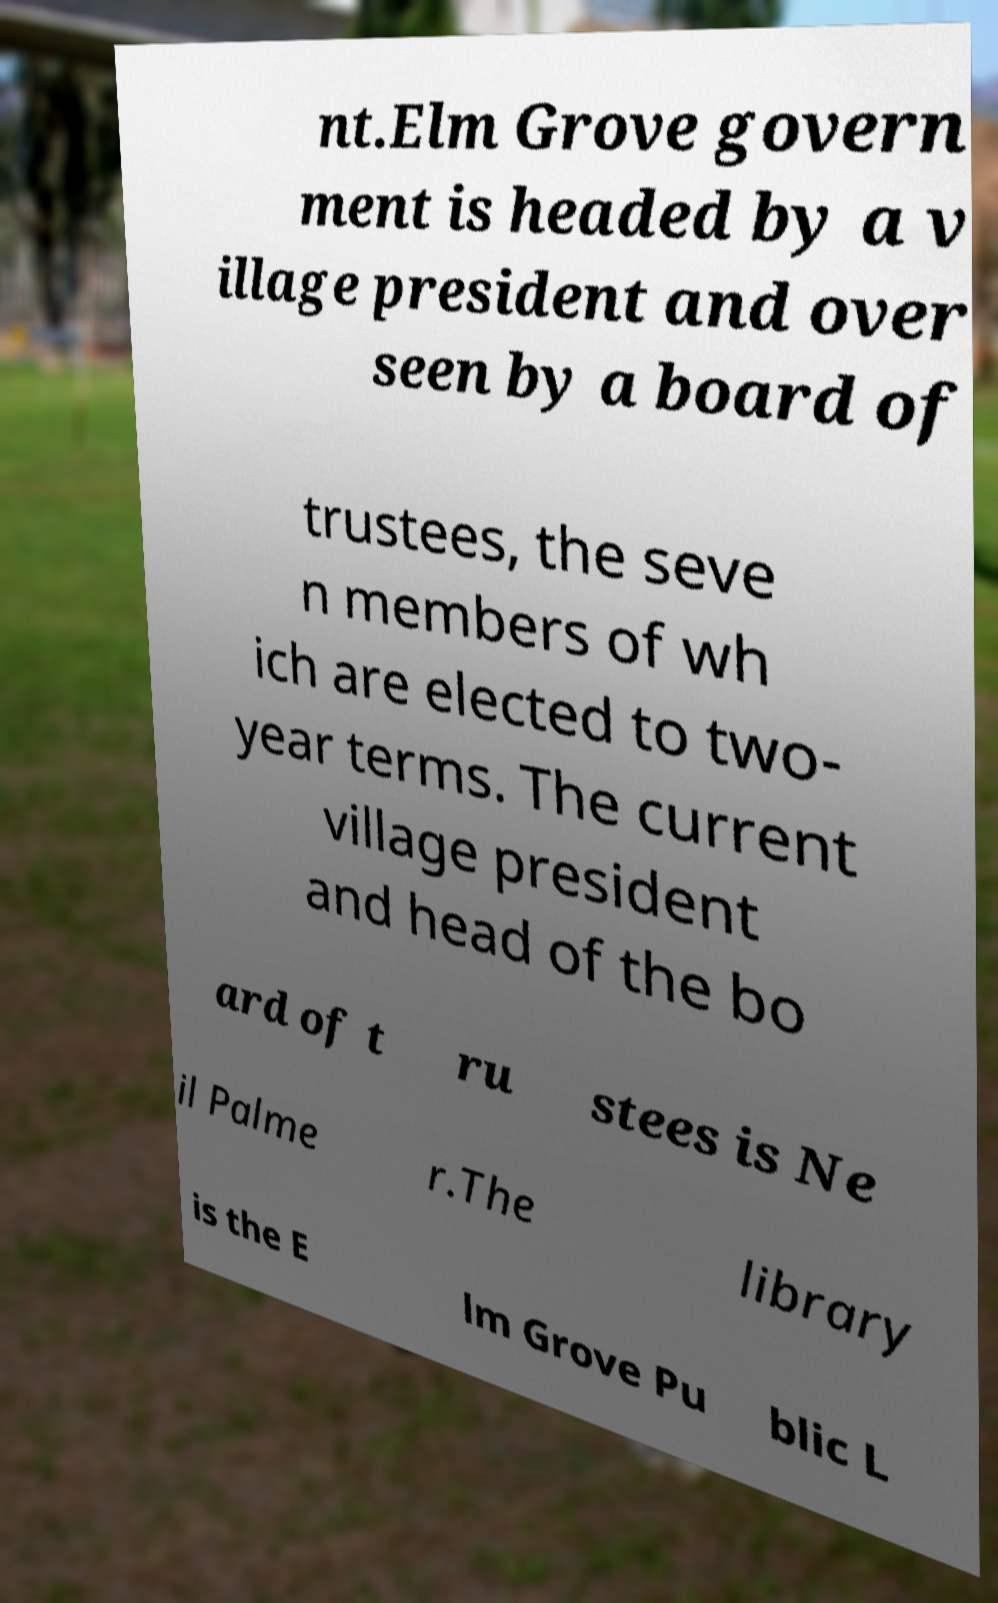Can you accurately transcribe the text from the provided image for me? nt.Elm Grove govern ment is headed by a v illage president and over seen by a board of trustees, the seve n members of wh ich are elected to two- year terms. The current village president and head of the bo ard of t ru stees is Ne il Palme r.The library is the E lm Grove Pu blic L 